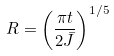Convert formula to latex. <formula><loc_0><loc_0><loc_500><loc_500>R = \left ( \frac { \pi t } { 2 { \bar { J } } } \right ) ^ { 1 / 5 }</formula> 